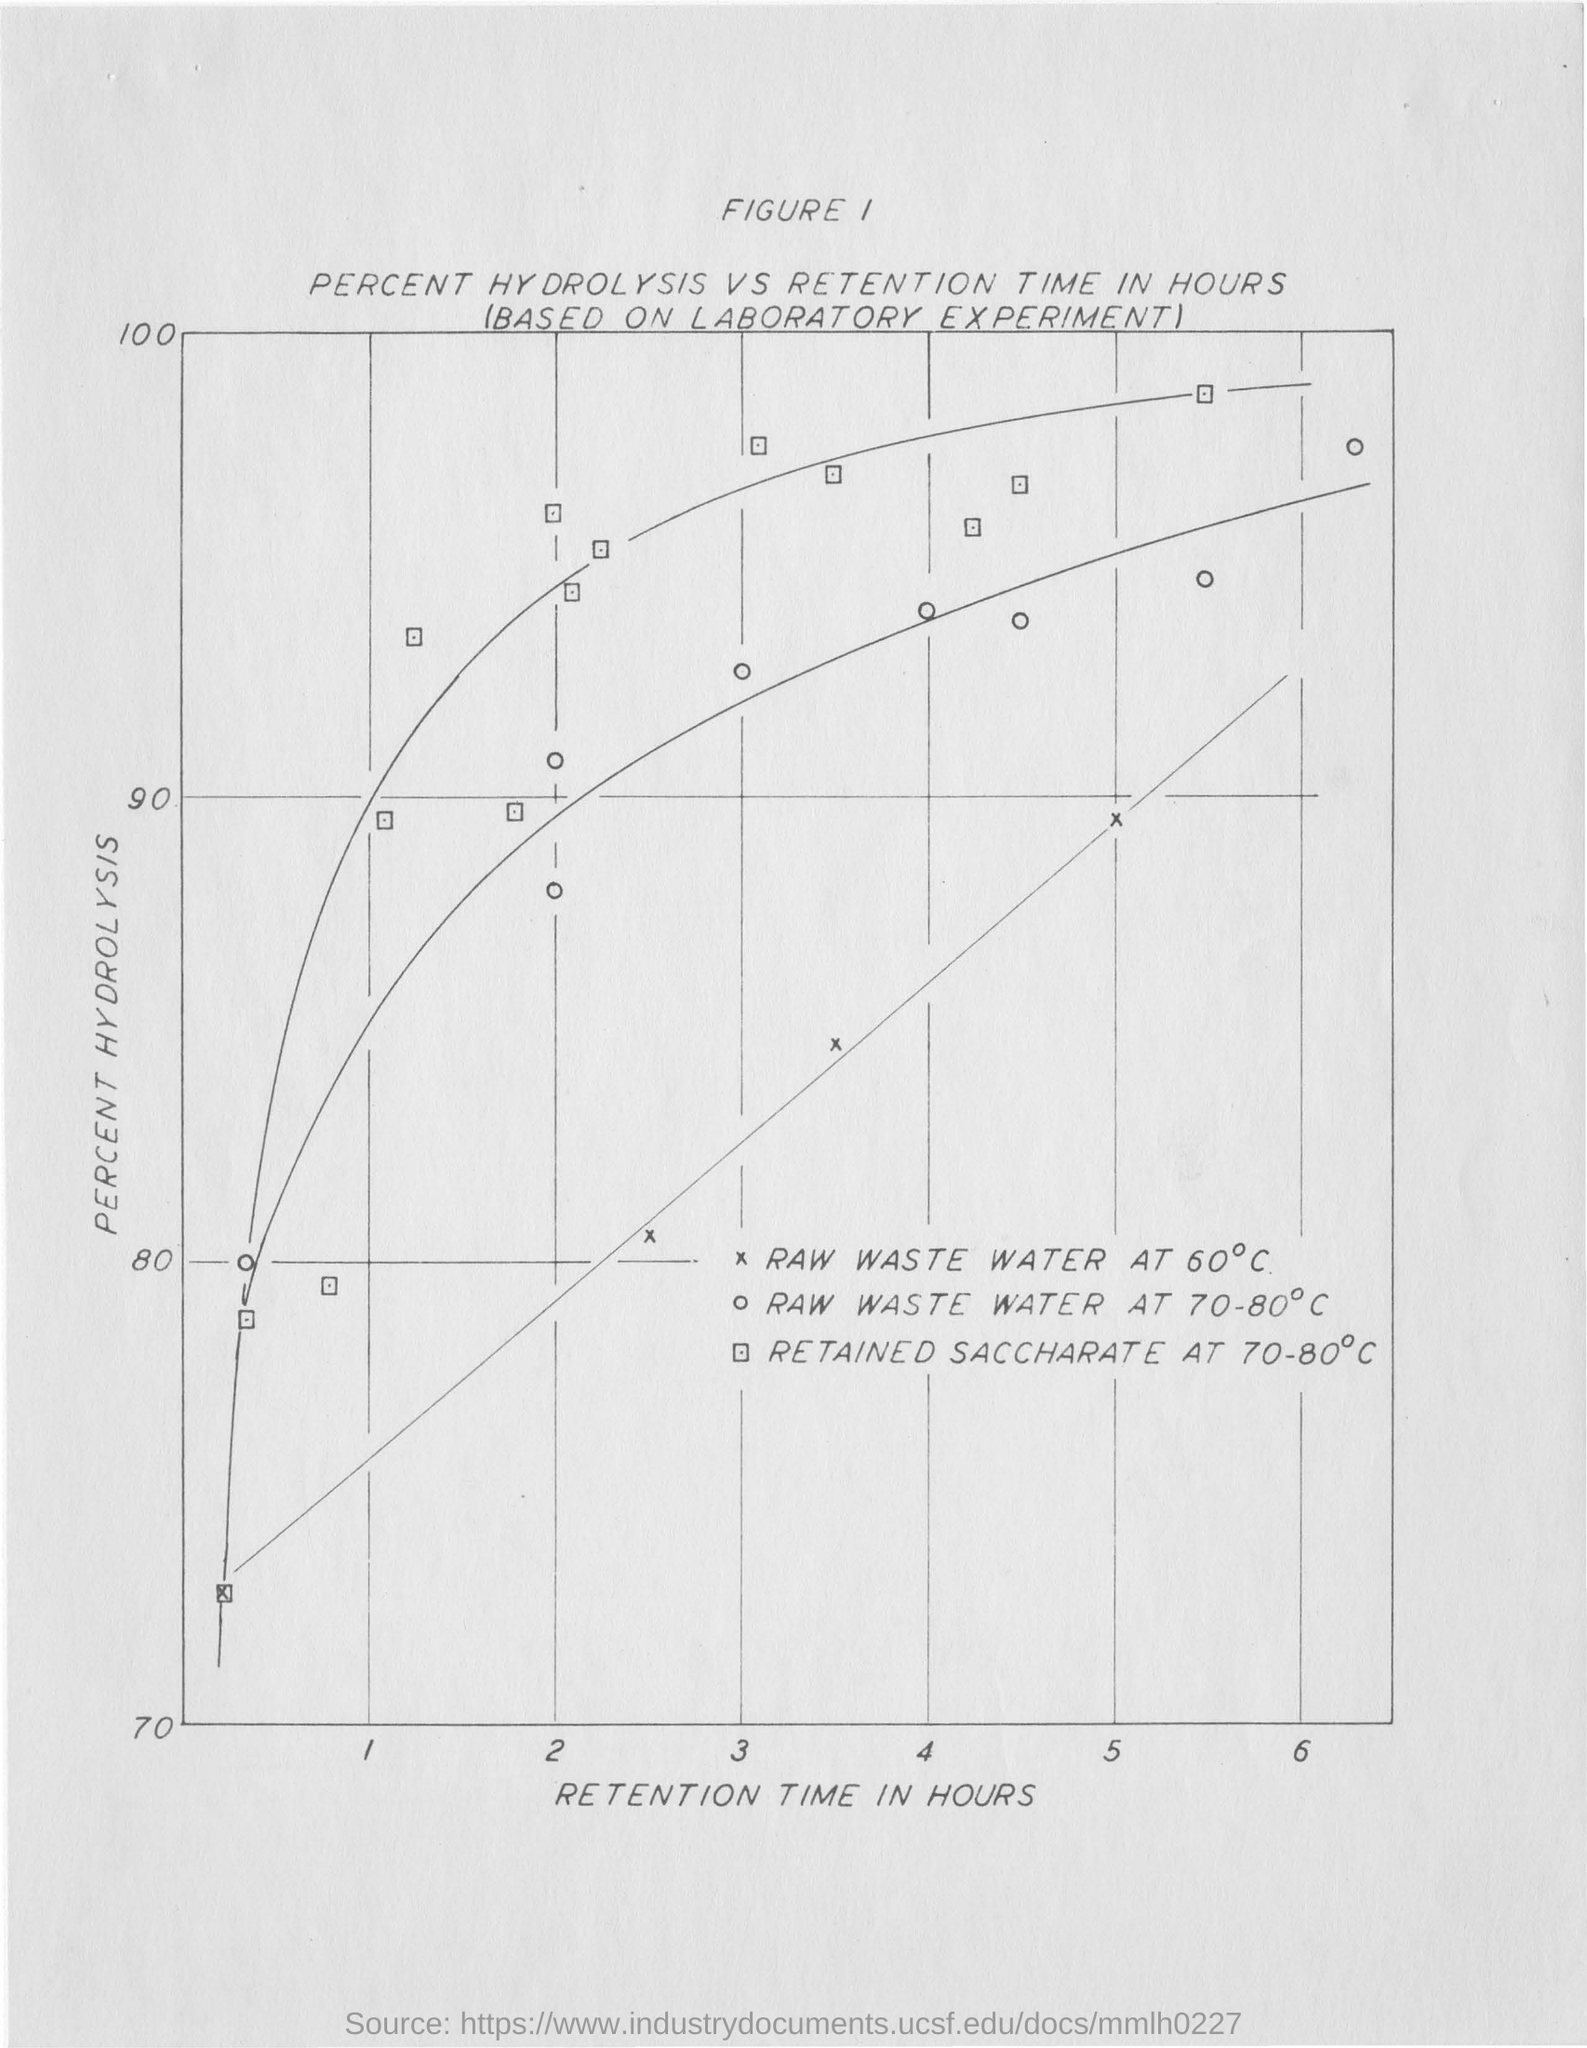Highlight a few significant elements in this photo. The parameter shown on the y-axis of the graph is the percent hydrolysis. The parameter given on the x-axis of the graph is retention time in hours. The graph shows the percent hydrolysis of a substance over time, measured in hours, based on a laboratory experiment. 